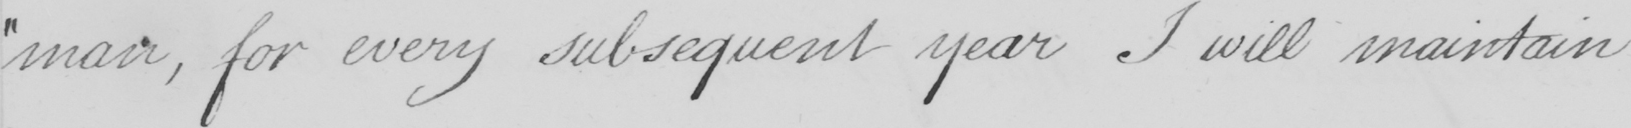Transcribe the text shown in this historical manuscript line. " man , for every subsequent year I will maintain 